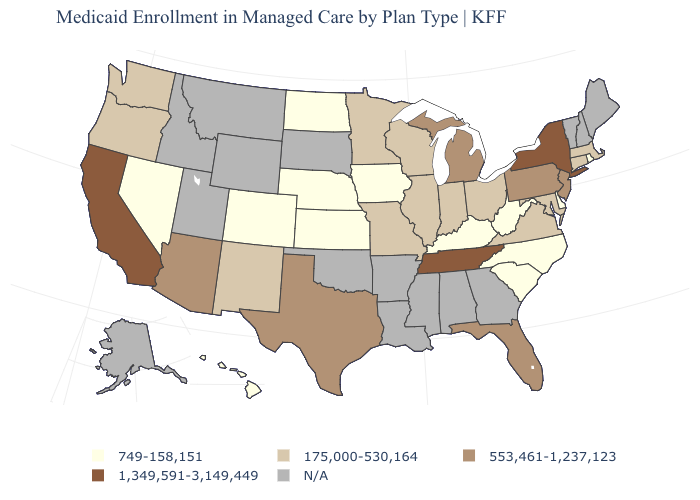Does Iowa have the lowest value in the USA?
Be succinct. Yes. Name the states that have a value in the range 749-158,151?
Keep it brief. Colorado, Delaware, Hawaii, Iowa, Kansas, Kentucky, Nebraska, Nevada, North Carolina, North Dakota, Rhode Island, South Carolina, West Virginia. Name the states that have a value in the range 175,000-530,164?
Keep it brief. Connecticut, Illinois, Indiana, Maryland, Massachusetts, Minnesota, Missouri, New Mexico, Ohio, Oregon, Virginia, Washington, Wisconsin. Is the legend a continuous bar?
Keep it brief. No. What is the value of Mississippi?
Quick response, please. N/A. What is the value of New York?
Answer briefly. 1,349,591-3,149,449. What is the lowest value in the USA?
Be succinct. 749-158,151. Which states have the lowest value in the USA?
Give a very brief answer. Colorado, Delaware, Hawaii, Iowa, Kansas, Kentucky, Nebraska, Nevada, North Carolina, North Dakota, Rhode Island, South Carolina, West Virginia. What is the lowest value in the USA?
Quick response, please. 749-158,151. What is the value of Washington?
Give a very brief answer. 175,000-530,164. Which states have the highest value in the USA?
Keep it brief. California, New York, Tennessee. Is the legend a continuous bar?
Quick response, please. No. What is the value of West Virginia?
Concise answer only. 749-158,151. Name the states that have a value in the range 553,461-1,237,123?
Short answer required. Arizona, Florida, Michigan, New Jersey, Pennsylvania, Texas. 